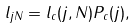Convert formula to latex. <formula><loc_0><loc_0><loc_500><loc_500>l _ { j N } = l _ { c } ( j , N ) P _ { c } ( j ) ,</formula> 